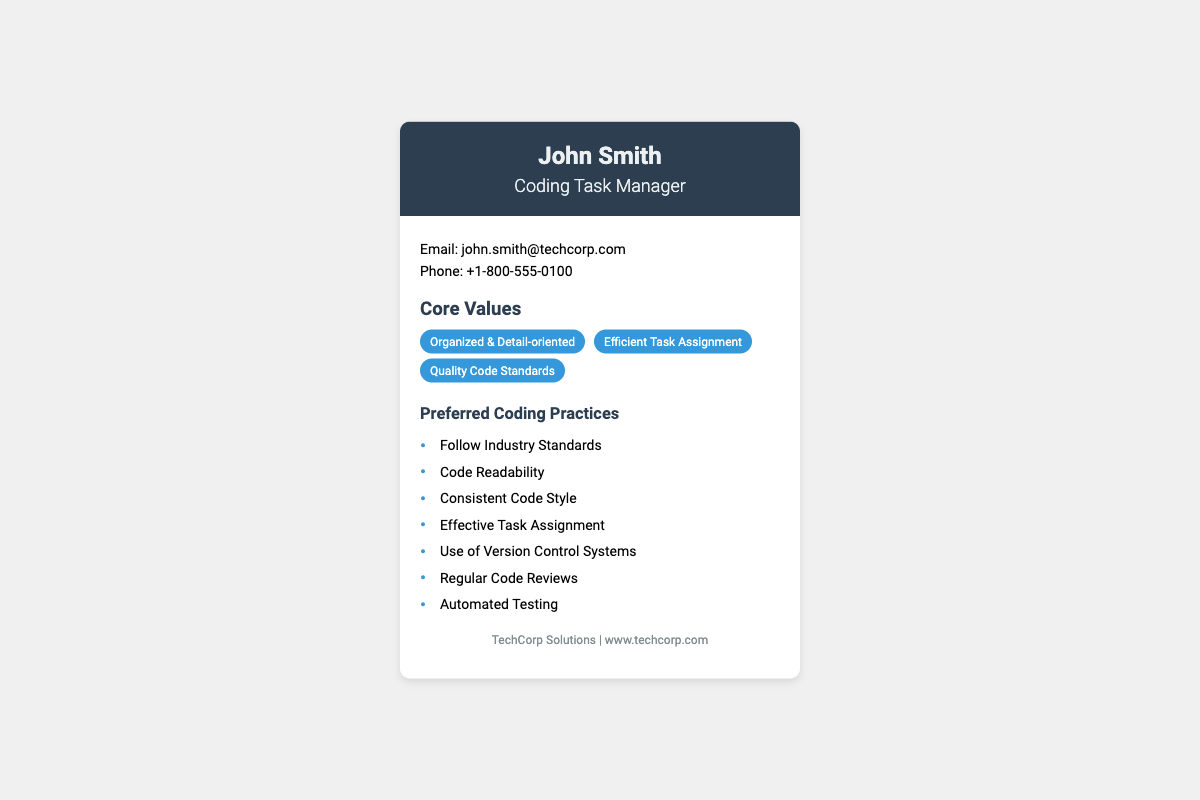What is the name of the Coding Task Manager? The name of the Coding Task Manager is displayed in the header section of the document.
Answer: John Smith What is the email address listed on the business card? The email address can be found in the contact info section of the card.
Answer: john.smith@techcorp.com How many core values are mentioned? The core values are listed in a bulleted format, and counting them gives the total.
Answer: 3 What is one preferred coding practice listed? The preferred coding practices are presented in a list, any one of them can be chosen.
Answer: Follow Industry Standards Which company does John Smith work for? The company information is provided at the bottom of the card.
Answer: TechCorp Solutions What is the phone number provided? The phone number is indicated in the contact information section of the document.
Answer: +1-800-555-0100 What is the primary focus of the coding practices? The coding practices aim to ensure quality and organized coding, evidenced by their titles.
Answer: Quality Code Standards What type of document is this? The structure and the content clearly outline this as a business card.
Answer: Business Card 